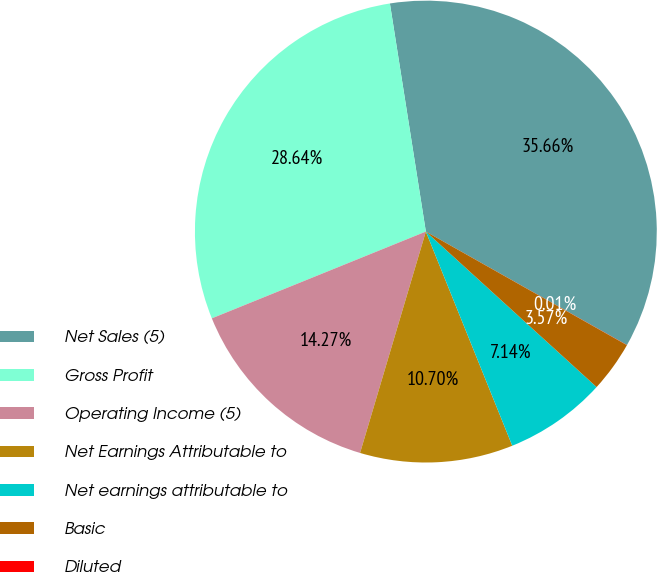Convert chart. <chart><loc_0><loc_0><loc_500><loc_500><pie_chart><fcel>Net Sales (5)<fcel>Gross Profit<fcel>Operating Income (5)<fcel>Net Earnings Attributable to<fcel>Net earnings attributable to<fcel>Basic<fcel>Diluted<nl><fcel>35.66%<fcel>28.64%<fcel>14.27%<fcel>10.7%<fcel>7.14%<fcel>3.57%<fcel>0.01%<nl></chart> 